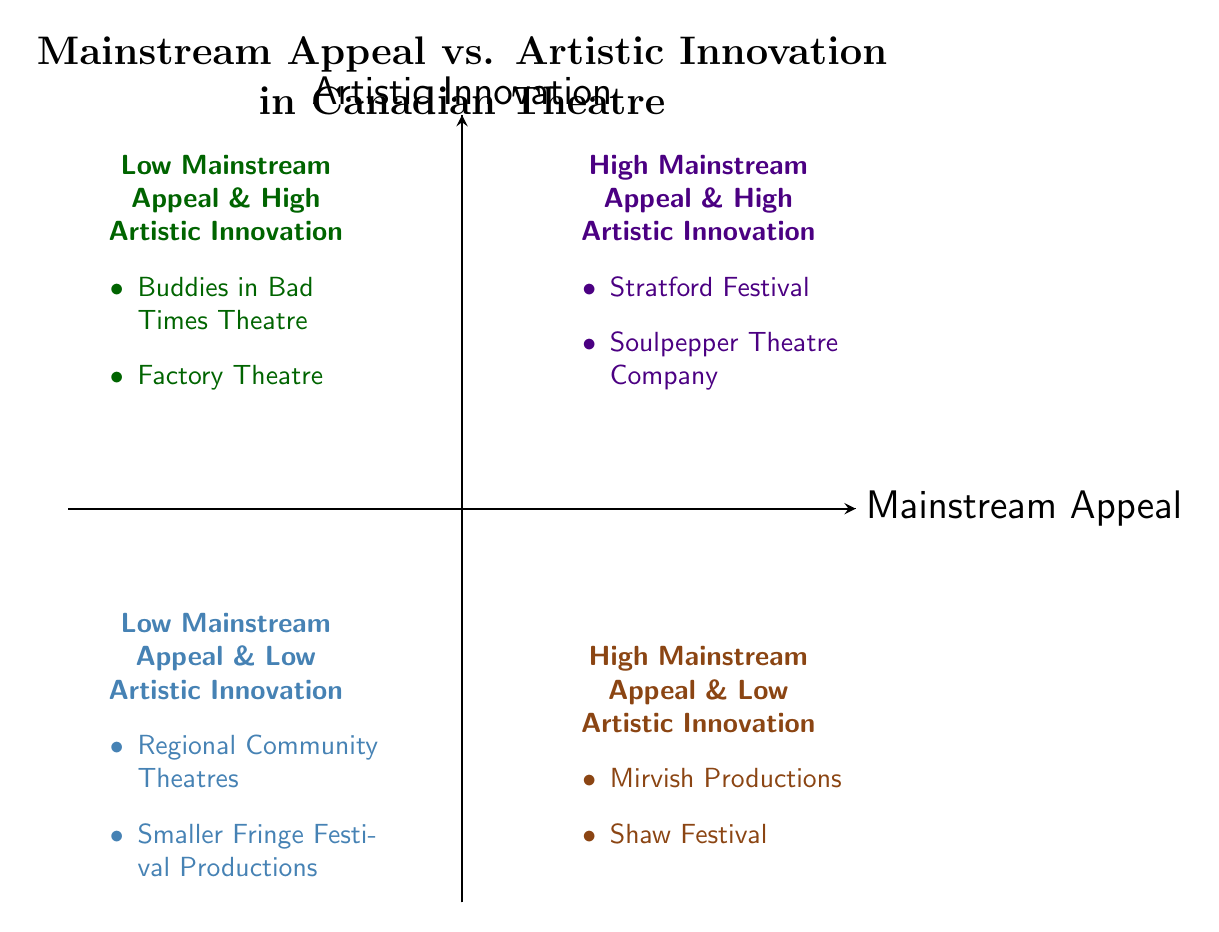What are the two examples in the High Mainstream Appeal & High Artistic Innovation quadrant? The diagram indicates two examples in the "High Mainstream Appeal & High Artistic Innovation" quadrant: Stratford Festival and Soulpepper Theatre Company.
Answer: Stratford Festival, Soulpepper Theatre Company How many quadrants are represented in the diagram? The diagram features four quadrants, each representing different combinations of mainstream appeal and artistic innovation.
Answer: Four What is the relationship between Mirvish Productions and Shaw Festival? Both Mirvish Productions and Shaw Festival are located in the "High Mainstream Appeal & Low Artistic Innovation" quadrant, indicating they share similarities regarding their mainstream appeal.
Answer: Same quadrant Which quadrant contains Buddies in Bad Times Theatre? Buddies in Bad Times Theatre is positioned in the "Low Mainstream Appeal & High Artistic Innovation" quadrant, which highlights its innovative performances despite lower mainstream recognition.
Answer: Low Mainstream Appeal & High Artistic Innovation In which quadrant do smaller Fringe Festival productions fall? Smaller Fringe Festival Productions reside in the "Low Mainstream Appeal & Low Artistic Innovation" quadrant, indicating a lack of both widespread appeal and innovative aspects.
Answer: Low Mainstream Appeal & Low Artistic Innovation How many examples are listed in the Low Mainstream Appeal & High Artistic Innovation quadrant? The diagram shows two examples in the "Low Mainstream Appeal & High Artistic Innovation" quadrant: Buddies in Bad Times Theatre and Factory Theatre.
Answer: Two Which theatre companies are in the High Mainstream Appeal & Low Artistic Innovation quadrant? The examples within the "High Mainstream Appeal & Low Artistic Innovation" quadrant are Mirvish Productions and Shaw Festival, demonstrating high appeal but low innovation.
Answer: Mirvish Productions, Shaw Festival What can be inferred about the Regional Community Theatres in the diagram? Regional Community Theatres are placed in the "Low Mainstream Appeal & Low Artistic Innovation" quadrant, suggesting they do not attract a large audience and lack innovative offerings.
Answer: Low Mainstream Appeal & Low Artistic Innovation Which quadrant is most indicative of artistic innovation among the examples? The "Low Mainstream Appeal & High Artistic Innovation" quadrant, containing Buddies in Bad Times Theatre and Factory Theatre, is most indicative of artistic innovation due to its emphasis on creativity.
Answer: Low Mainstream Appeal & High Artistic Innovation 